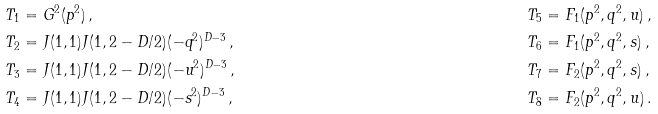Convert formula to latex. <formula><loc_0><loc_0><loc_500><loc_500>& T _ { 1 } = G ^ { 2 } ( p ^ { 2 } ) \, , & & T _ { 5 } = F _ { 1 } ( p ^ { 2 } , q ^ { 2 } , u ) \, , \\ & T _ { 2 } = J ( 1 , 1 ) J ( 1 , 2 - D / 2 ) ( - q ^ { 2 } ) ^ { D - 3 } \, , & & T _ { 6 } = F _ { 1 } ( p ^ { 2 } , q ^ { 2 } , s ) \, , \\ & T _ { 3 } = J ( 1 , 1 ) J ( 1 , 2 - D / 2 ) ( - u ^ { 2 } ) ^ { D - 3 } \, , & & T _ { 7 } = F _ { 2 } ( p ^ { 2 } , q ^ { 2 } , s ) \, , \\ & T _ { 4 } = J ( 1 , 1 ) J ( 1 , 2 - D / 2 ) ( - s ^ { 2 } ) ^ { D - 3 } \, , & & T _ { 8 } = F _ { 2 } ( p ^ { 2 } , q ^ { 2 } , u ) \, .</formula> 